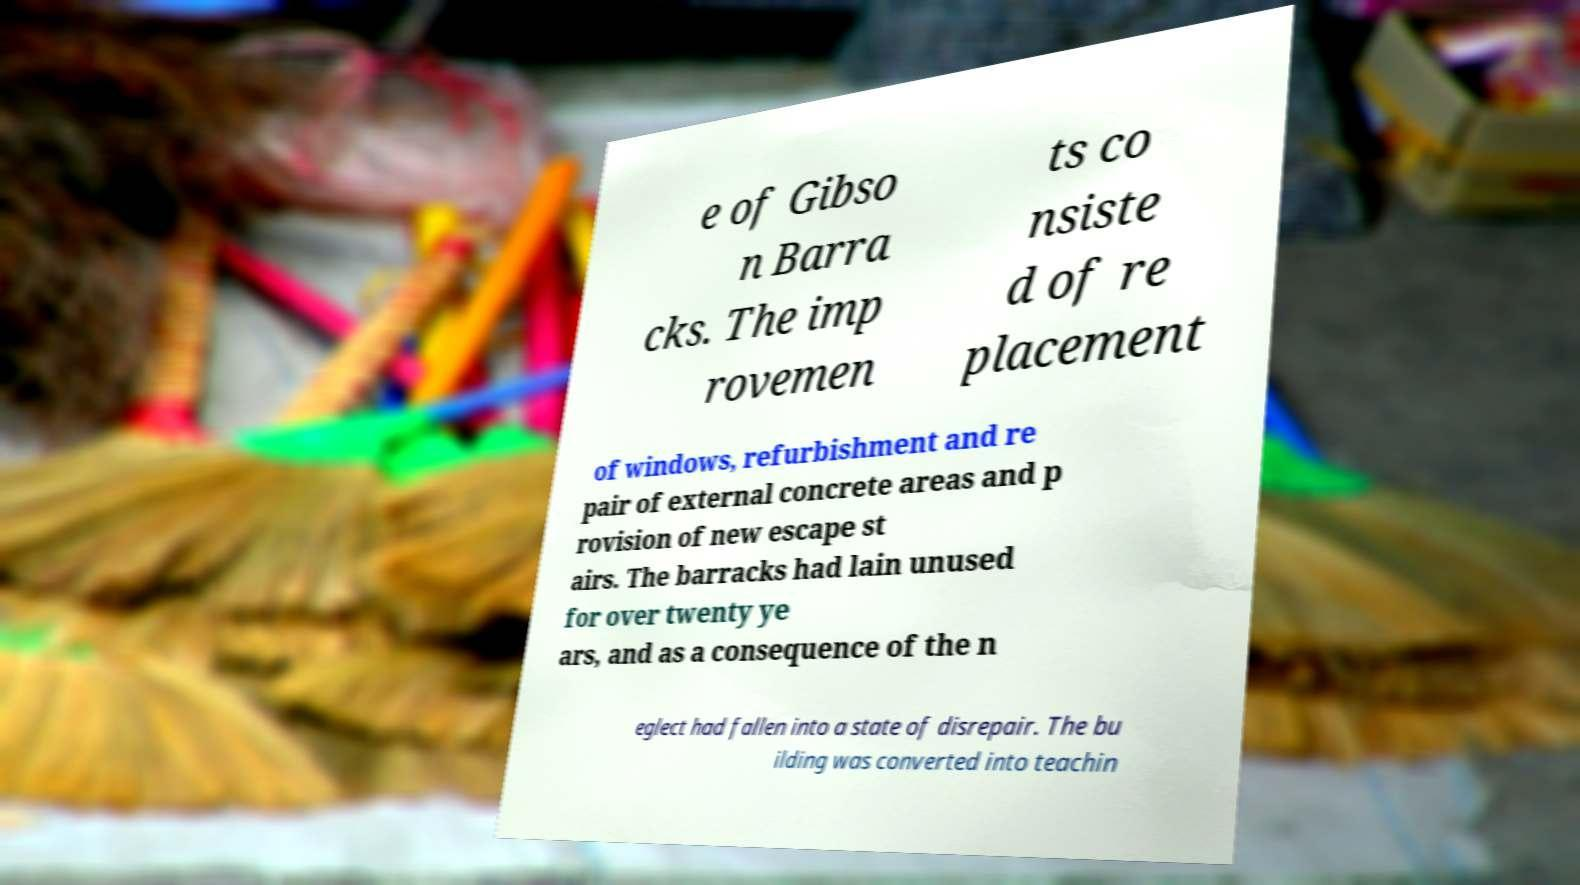There's text embedded in this image that I need extracted. Can you transcribe it verbatim? e of Gibso n Barra cks. The imp rovemen ts co nsiste d of re placement of windows, refurbishment and re pair of external concrete areas and p rovision of new escape st airs. The barracks had lain unused for over twenty ye ars, and as a consequence of the n eglect had fallen into a state of disrepair. The bu ilding was converted into teachin 